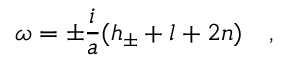Convert formula to latex. <formula><loc_0><loc_0><loc_500><loc_500>\omega = \pm \frac { i } { a } ( h _ { \pm } + l + 2 n ) \quad ,</formula> 